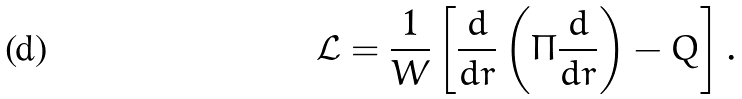<formula> <loc_0><loc_0><loc_500><loc_500>\mathcal { L } & = \frac { 1 } { W } \left [ \frac { d } { d r } \left ( \Pi \frac { d } { d r } \right ) - Q \right ] .</formula> 